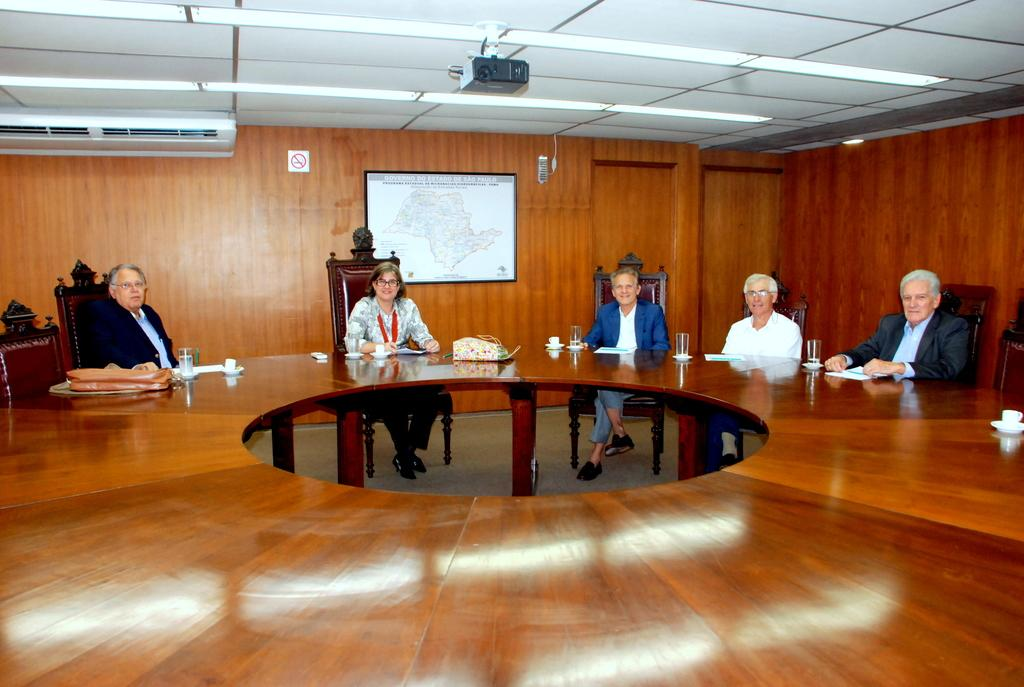How many people are present in the image? There are 5 people in the image. What are the people doing in the image? The people are sitting on chairs. How are the chairs arranged in the image? The chairs are arranged around a big table. What can be seen on the wall behind the people? There is a frame on the wall. What other object is present on the wall? There is an air conditioning unit (AC) on the wall. Can you describe the location of the projector in the image? The projector is on the roof top. How does the feeling of love manifest itself in the image? There is no indication of love or any emotions in the image; it simply shows people sitting around a table. 